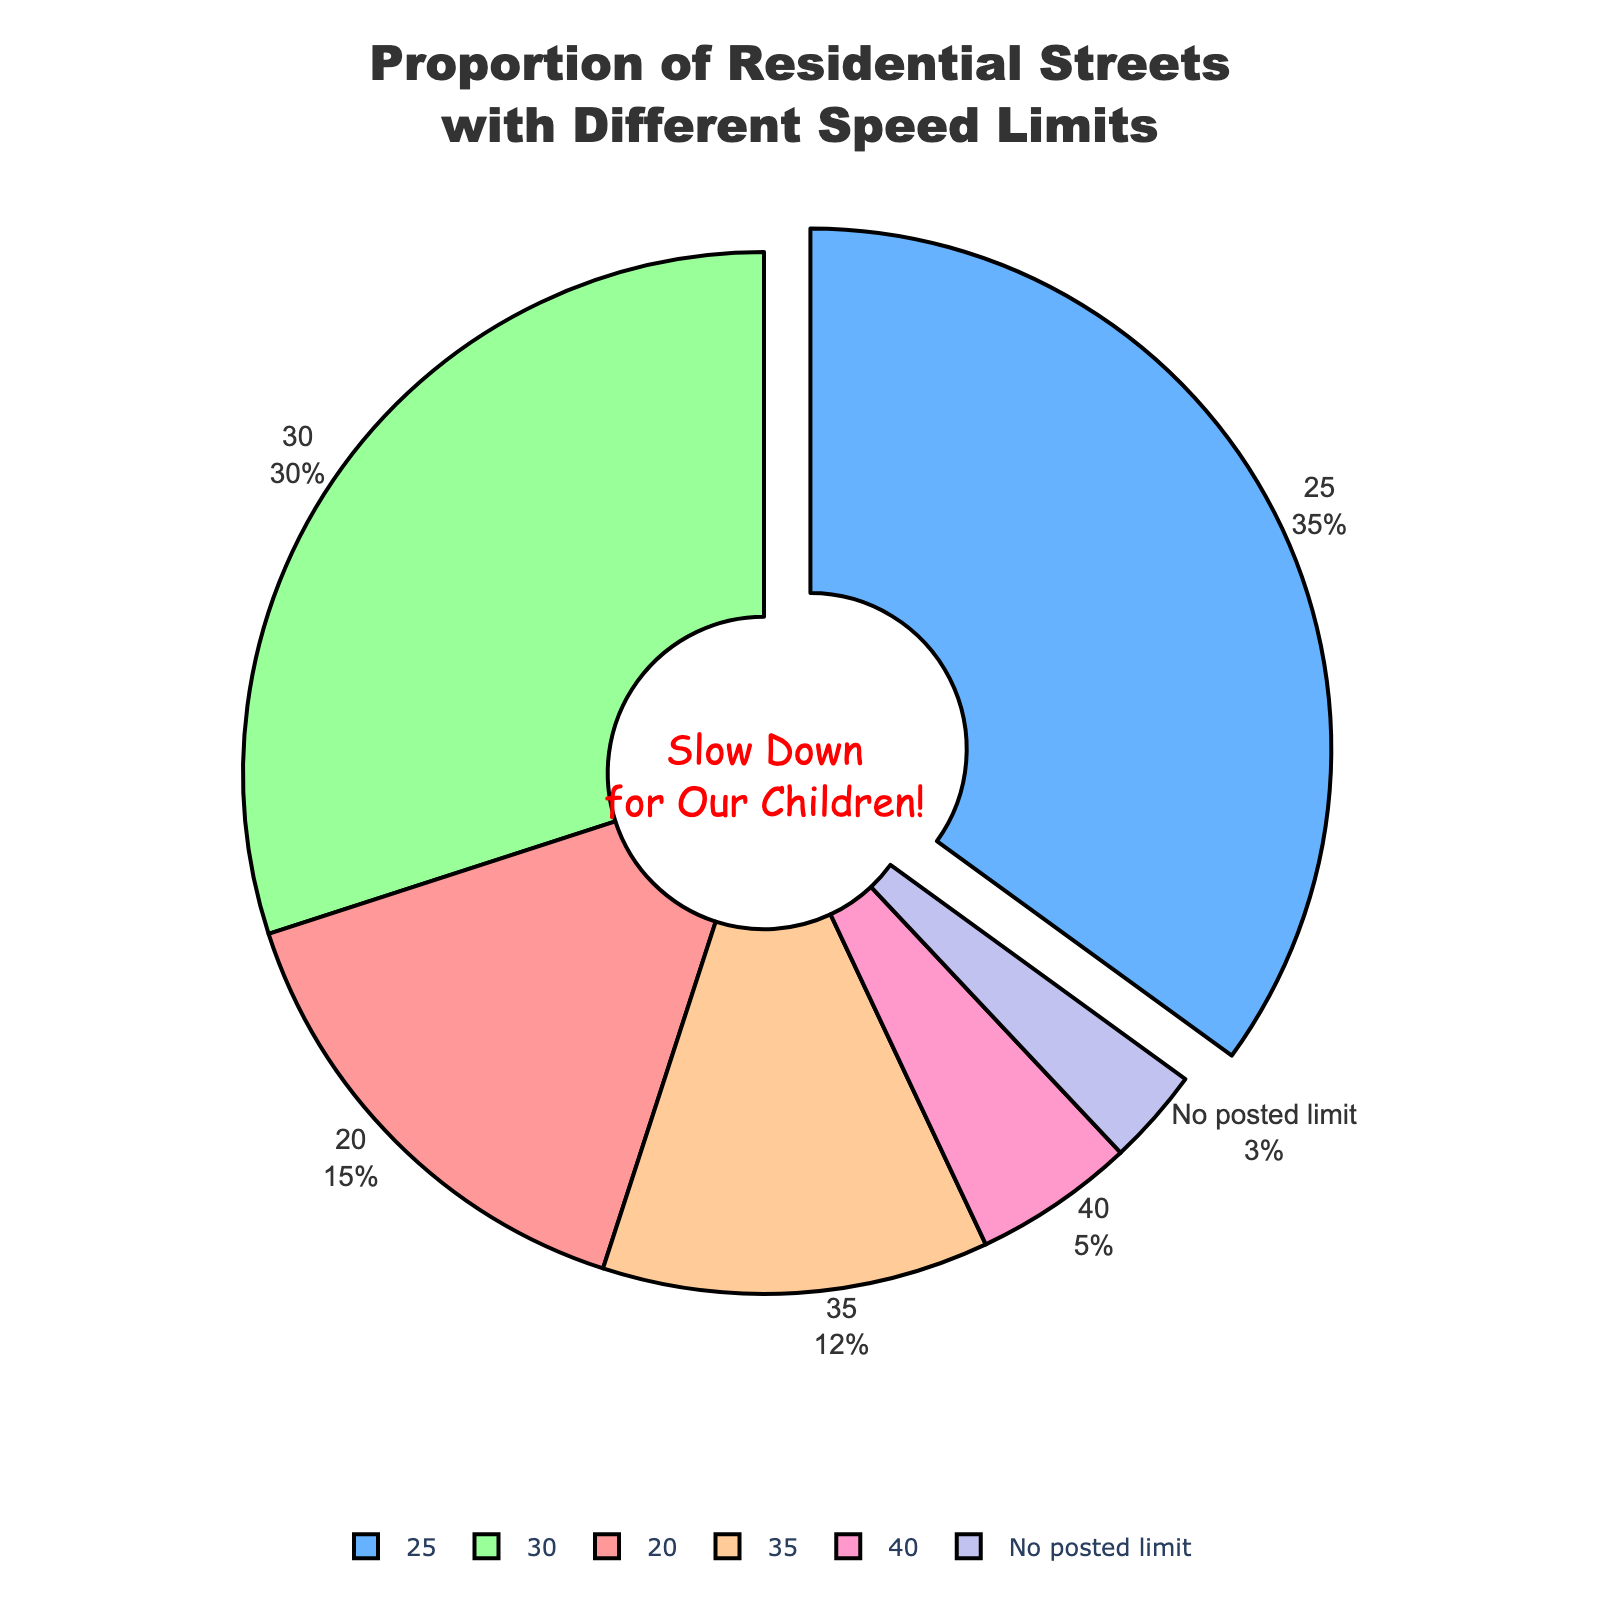What proportion of residential streets have a speed limit of 20 mph? Locate the segment labeled '20' in the pie chart. The percentage indicated is 15%.
Answer: 15% How much greater is the proportion of streets with a 25 mph limit compared to those with a 35 mph limit? Compare the segments labeled '25' and '35'. The proportion for 25 mph is 35% and for 35 mph is 12%. The difference is 35% - 12% = 23%.
Answer: 23% What is the total proportion of residential streets with no posted limit and with a 40 mph limit combined? Add the percentages of the segments labeled 'No posted limit' and '40'. The sum is 3% + 5% = 8%.
Answer: 8% Which speed limit category is represented by the largest segment in the chart? Identify the largest segment visually. The segment labeled '25' is the largest at 35%.
Answer: 25 mph Does a higher proportion of residential streets have a speed limit of 30 mph or 20 mph? Compare the segments labeled '30' and '20'. The proportion for 30 mph is 30%, and for 20 mph is 15%. 30 mph has a higher proportion.
Answer: 30 mph What color represents streets with a speed limit of 35 mph? Visually find the segment labeled '35'. The segment color is an orange shade.
Answer: Orange What speed limits combined make up more than half of the residential streets? Combine the percentages to reach over 50%. 25 mph is 35%, 30 mph is 30%, adding to 65%, which exceeds half.
Answer: 25 mph and 30 mph What's the combined proportion of streets with speed limits of 20 mph, 30 mph, and 40 mph? Add the percentages for 20 mph, 30 mph, and 40 mph. 15% + 30% + 5% = 50%.
Answer: 50% How much smaller is the proportion of streets with a 40 mph limit compared to those with a 20 mph limit? Compare the percentages for 40 mph and 20 mph. The difference is 15% - 5% = 10%.
Answer: 10% Which speed limit category has the second-largest proportion in the chart? Identify the second-largest segment after the largest one (25 mph, 35%). The next largest is 30 mph at 30%.
Answer: 30 mph 